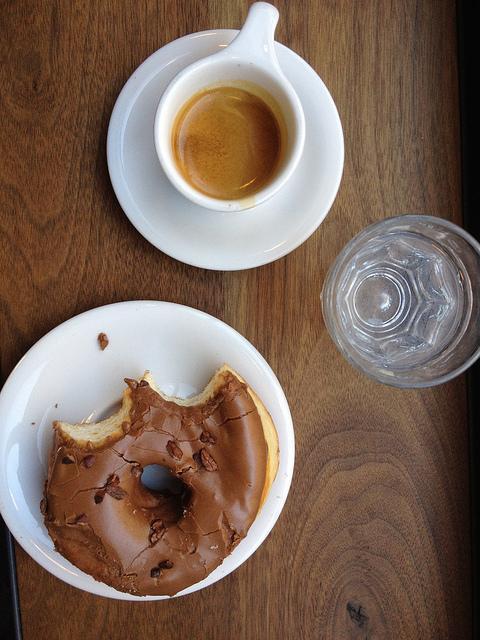How many cups can be seen?
Give a very brief answer. 2. 